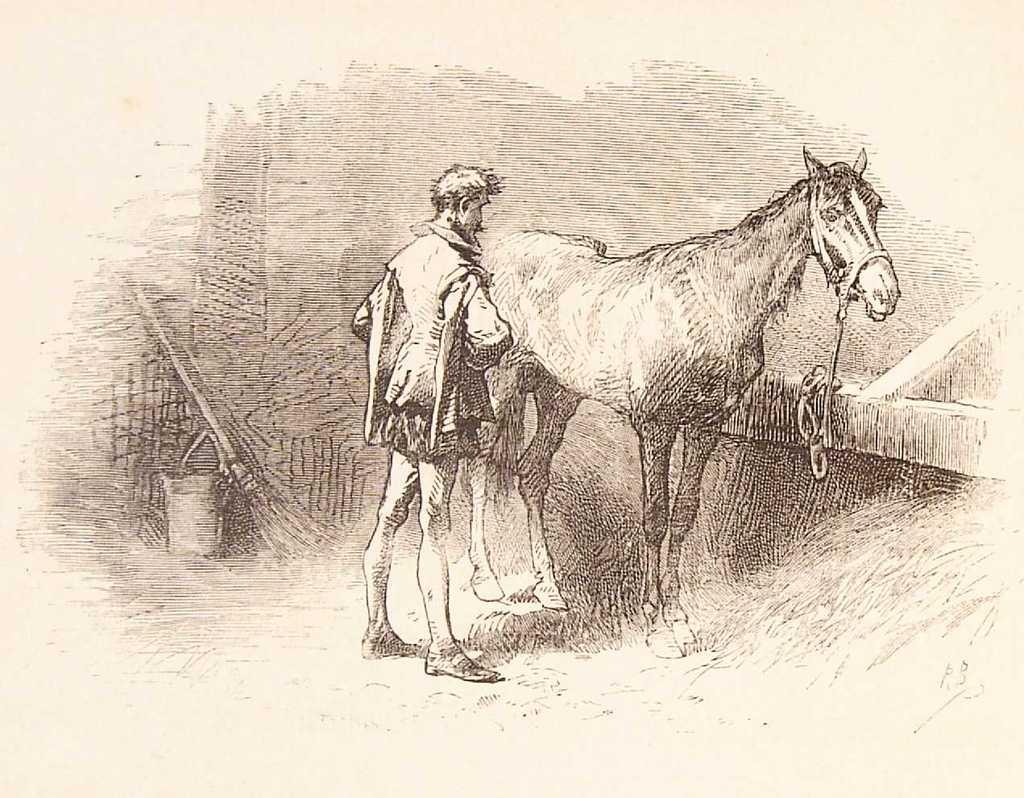What type of drawings are present in the image? There is a drawing of a person and a drawing of a horse in the image. Where are the drawings located in the image? The drawings are on the ground. What type of window can be seen in the drawing of the horse? There is no window present in the drawing of the horse; it is a drawing of a horse without any additional elements. 